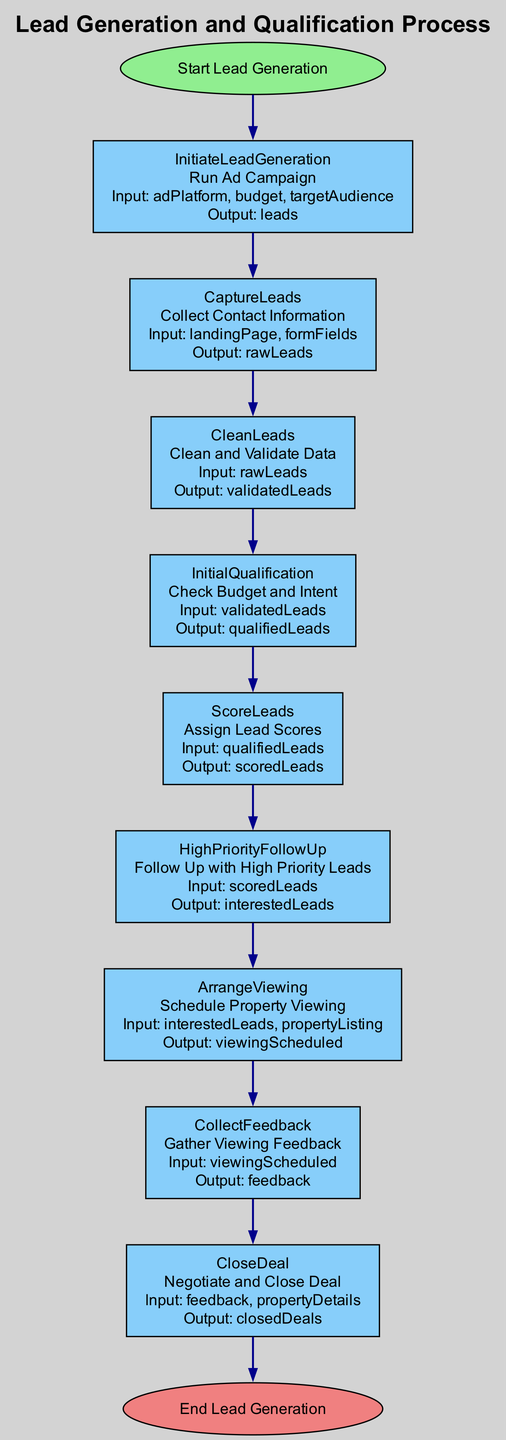What is the first action in the process? The first action listed in the steps of the flowchart is "Run Ad Campaign." This is represented in the "InitiateLeadGeneration" node, which is directly after the "Start Lead Generation" node.
Answer: Run Ad Campaign How many steps are there in the process? The diagram lists a total of nine steps that are detailed under the "steps" section. This includes the initial step "InitiateLeadGeneration" and progresses through to "CloseDeal."
Answer: Nine What is the output of the "CleanLeads" step? The output specified for "CleanLeads" step in the flowchart is "validatedLeads." This indicates the result of cleaning and validating the raw leads collected earlier.
Answer: validatedLeads Which step follows "ScoreLeads"? The step that follows "ScoreLeads" is "HighPriorityFollowUp." In the flowchart, it is directly connected to the "ScoreLeads" step.
Answer: HighPriorityFollowUp What action is performed in the "CloseDeal" step? The action specified in the "CloseDeal" step is "Negotiate and Close Deal." This describes the final action taken at this stage of the process.
Answer: Negotiate and Close Deal In which step is feedback gathered? Feedback is gathered in the "CollectFeedback" step. This occurs after "ArrangeViewing," where property viewings with interested leads have been scheduled.
Answer: CollectFeedback What connects "ArrangeViewing" and "CollectFeedback"? The connection between "ArrangeViewing" and "CollectFeedback" is represented by a directed edge showing the flow of the process from scheduling property viewings to gathering feedback from those viewings. This indicates the sequence of actions taken.
Answer: Directed edge Which parameters are required for the "CaptureLeads" action? The required parameters for the "CaptureLeads" action are "landingPage" and "formFields." These parameters are essential to collect the contact information of leads.
Answer: landingPage, formFields What is the final output of the lead generation process? The final output stated in the process is "closedDeals," which is the result of negotiating and closing deals based on the feedback received.
Answer: closedDeals 